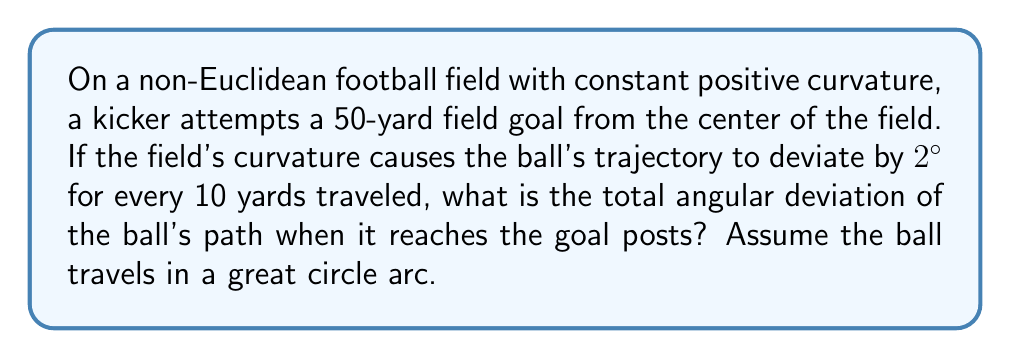Solve this math problem. Let's approach this step-by-step:

1) First, we need to understand that on a curved surface, straight lines are represented by geodesics or great circle arcs. The ball's path will follow such an arc.

2) We're given that the deviation is 2° for every 10 yards. Let's express this as a rate:

   Rate of deviation = $\frac{2°}{10 \text{ yards}} = 0.2° \text{ per yard}$

3) The field goal attempt is 50 yards. To find the total deviation, we multiply the rate by the distance:

   Total deviation = Rate of deviation × Distance
   $$ \text{Total deviation} = 0.2° \text{ per yard} \times 50 \text{ yards} $$

4) Let's calculate:
   $$ \text{Total deviation} = 0.2 \times 50 = 10° $$

5) Therefore, when the ball reaches the goal posts after traveling 50 yards on this curved field, its path will have deviated by 10° from a straight line in Euclidean space.

This result demonstrates how the curvature of a non-Euclidean field can significantly affect the trajectory of a kicked football, potentially changing the outcome of field goal attempts.
Answer: 10° 